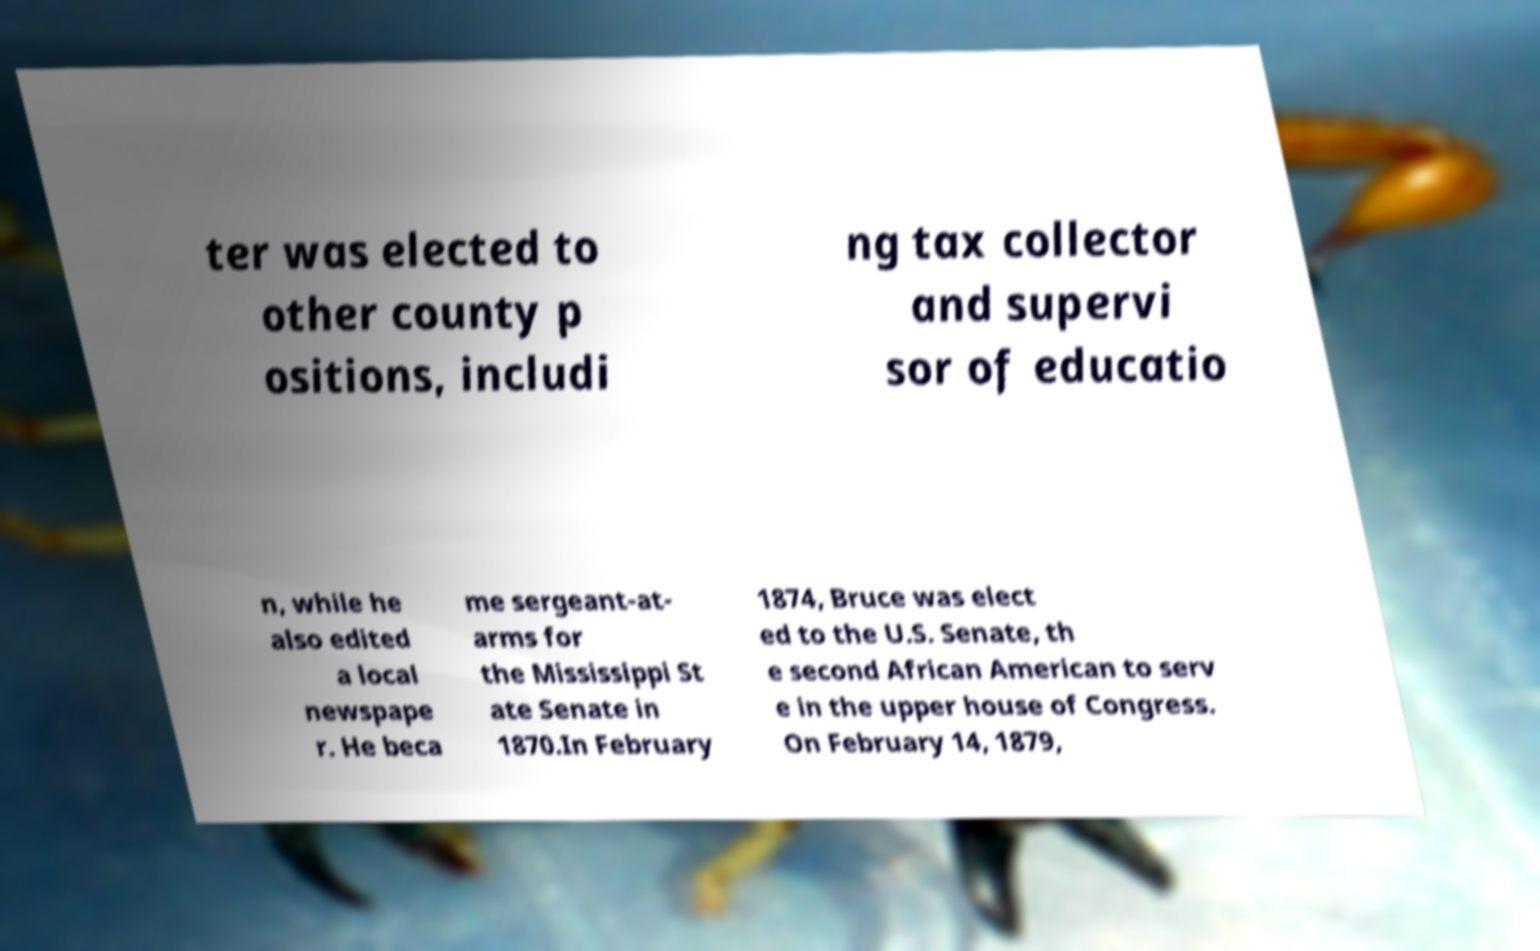Please identify and transcribe the text found in this image. ter was elected to other county p ositions, includi ng tax collector and supervi sor of educatio n, while he also edited a local newspape r. He beca me sergeant-at- arms for the Mississippi St ate Senate in 1870.In February 1874, Bruce was elect ed to the U.S. Senate, th e second African American to serv e in the upper house of Congress. On February 14, 1879, 